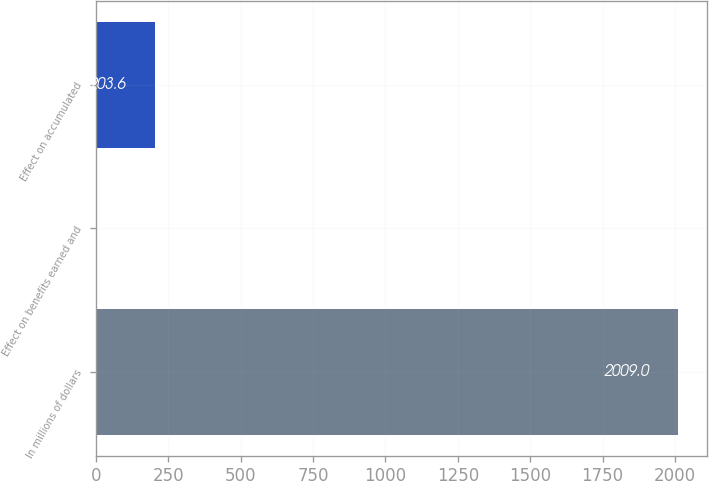Convert chart. <chart><loc_0><loc_0><loc_500><loc_500><bar_chart><fcel>In millions of dollars<fcel>Effect on benefits earned and<fcel>Effect on accumulated<nl><fcel>2009<fcel>3<fcel>203.6<nl></chart> 